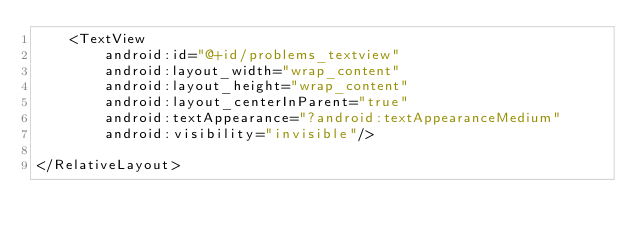<code> <loc_0><loc_0><loc_500><loc_500><_XML_>    <TextView
        android:id="@+id/problems_textview"
        android:layout_width="wrap_content"
        android:layout_height="wrap_content"
        android:layout_centerInParent="true"
        android:textAppearance="?android:textAppearanceMedium"
        android:visibility="invisible"/>

</RelativeLayout>
</code> 